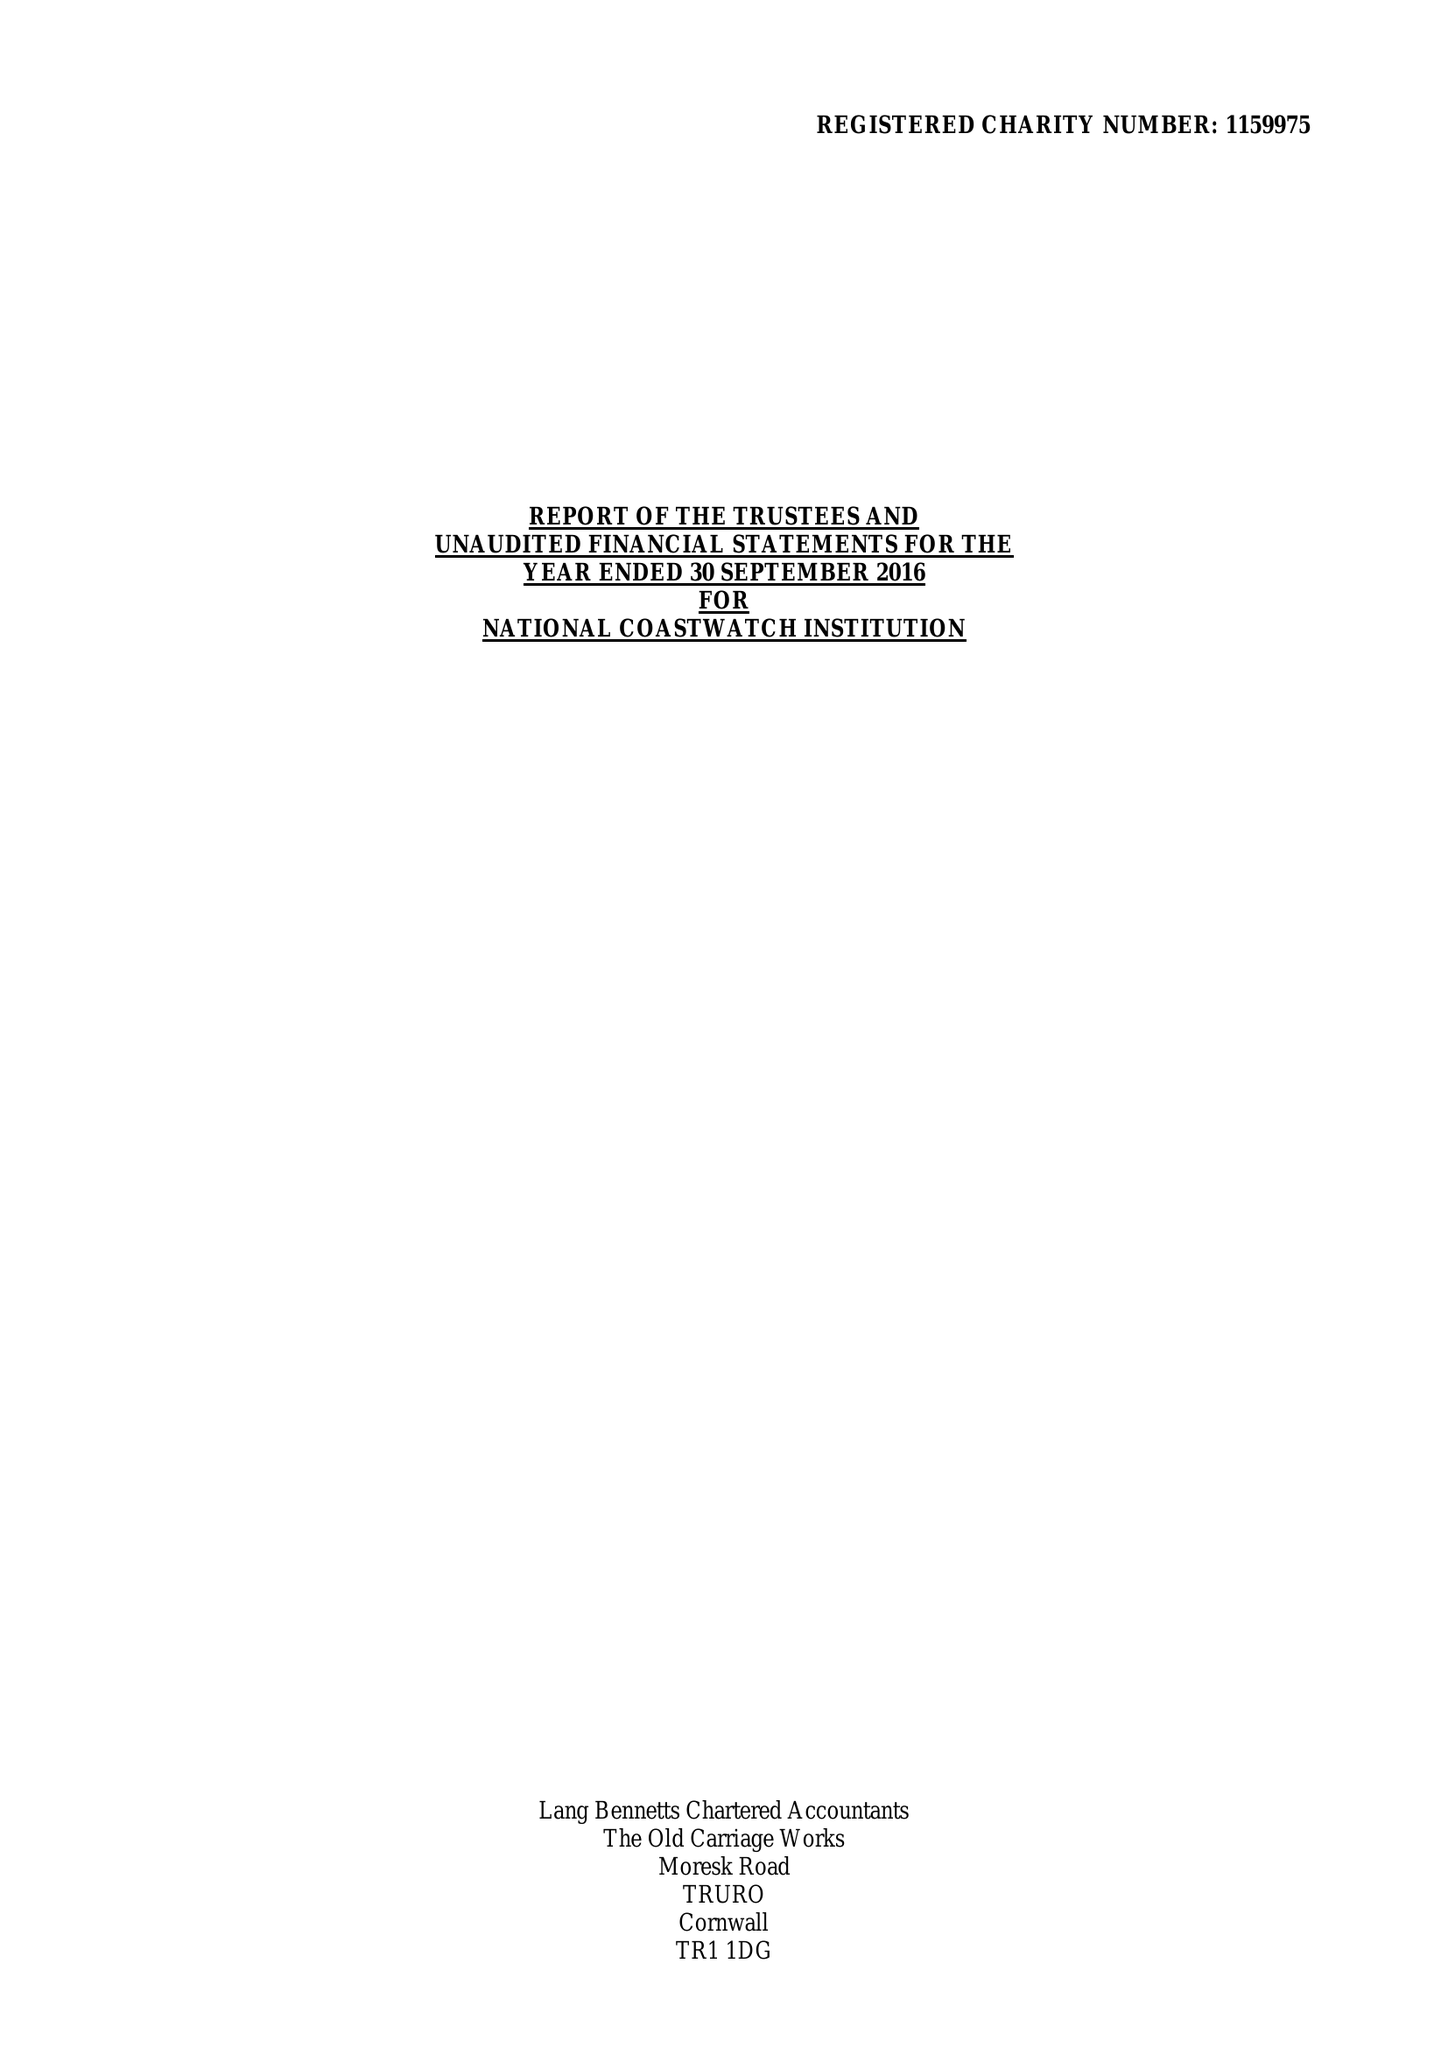What is the value for the income_annually_in_british_pounds?
Answer the question using a single word or phrase. 1577175.00 